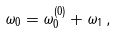<formula> <loc_0><loc_0><loc_500><loc_500>\omega _ { 0 } = \omega _ { 0 } ^ { ( 0 ) } + \omega _ { 1 } \, ,</formula> 